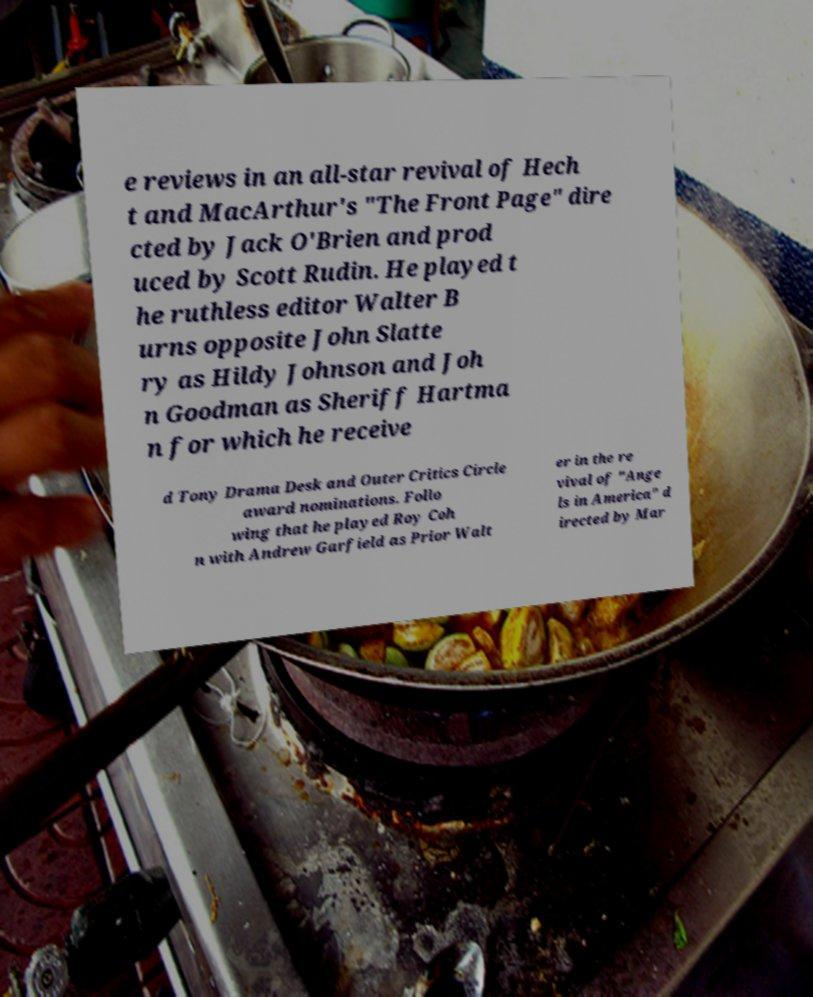I need the written content from this picture converted into text. Can you do that? e reviews in an all-star revival of Hech t and MacArthur's "The Front Page" dire cted by Jack O'Brien and prod uced by Scott Rudin. He played t he ruthless editor Walter B urns opposite John Slatte ry as Hildy Johnson and Joh n Goodman as Sheriff Hartma n for which he receive d Tony Drama Desk and Outer Critics Circle award nominations. Follo wing that he played Roy Coh n with Andrew Garfield as Prior Walt er in the re vival of "Ange ls in America" d irected by Mar 